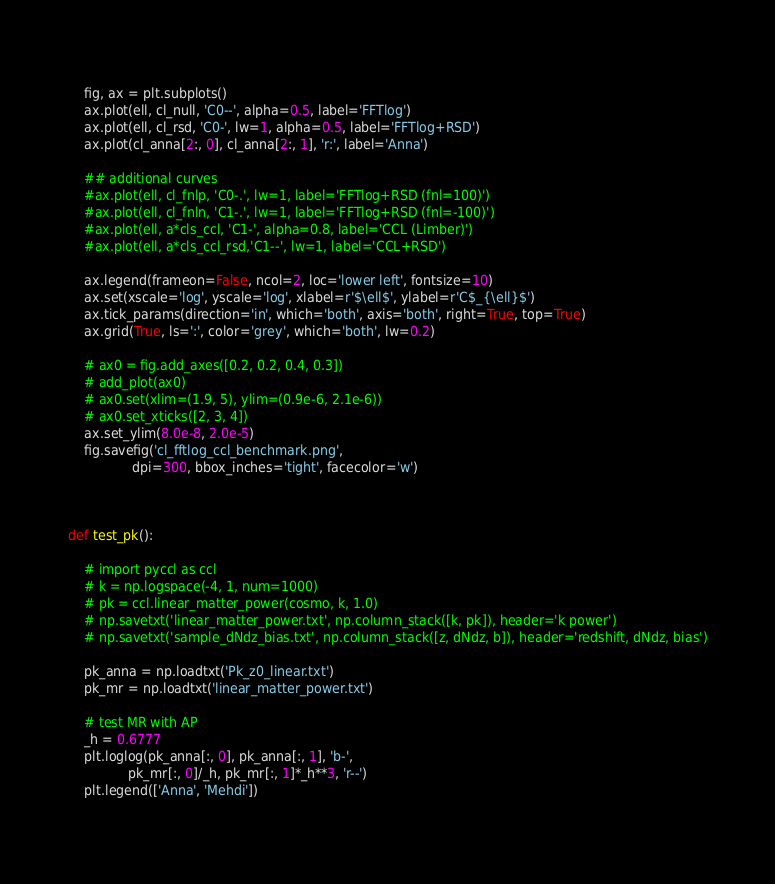Convert code to text. <code><loc_0><loc_0><loc_500><loc_500><_Python_>    
    fig, ax = plt.subplots()
    ax.plot(ell, cl_null, 'C0--', alpha=0.5, label='FFTlog')
    ax.plot(ell, cl_rsd, 'C0-', lw=1, alpha=0.5, label='FFTlog+RSD')
    ax.plot(cl_anna[2:, 0], cl_anna[2:, 1], 'r:', label='Anna')
    
    ## additional curves
    #ax.plot(ell, cl_fnlp, 'C0-.', lw=1, label='FFTlog+RSD (fnl=100)')   
    #ax.plot(ell, cl_fnln, 'C1-.', lw=1, label='FFTlog+RSD (fnl=-100)')    
    #ax.plot(ell, a*cls_ccl, 'C1-', alpha=0.8, label='CCL (Limber)')
    #ax.plot(ell, a*cls_ccl_rsd,'C1--', lw=1, label='CCL+RSD')

    ax.legend(frameon=False, ncol=2, loc='lower left', fontsize=10)
    ax.set(xscale='log', yscale='log', xlabel=r'$\ell$', ylabel=r'C$_{\ell}$')
    ax.tick_params(direction='in', which='both', axis='both', right=True, top=True)
    ax.grid(True, ls=':', color='grey', which='both', lw=0.2)

    # ax0 = fig.add_axes([0.2, 0.2, 0.4, 0.3])
    # add_plot(ax0)
    # ax0.set(xlim=(1.9, 5), ylim=(0.9e-6, 2.1e-6))
    # ax0.set_xticks([2, 3, 4])
    ax.set_ylim(8.0e-8, 2.0e-5)
    fig.savefig('cl_fftlog_ccl_benchmark.png', 
                dpi=300, bbox_inches='tight', facecolor='w')    

    
    
def test_pk():
    
    # import pyccl as ccl
    # k = np.logspace(-4, 1, num=1000)
    # pk = ccl.linear_matter_power(cosmo, k, 1.0)
    # np.savetxt('linear_matter_power.txt', np.column_stack([k, pk]), header='k power')
    # np.savetxt('sample_dNdz_bias.txt', np.column_stack([z, dNdz, b]), header='redshift, dNdz, bias')
    
    pk_anna = np.loadtxt('Pk_z0_linear.txt')
    pk_mr = np.loadtxt('linear_matter_power.txt')
    
    # test MR with AP
    _h = 0.6777
    plt.loglog(pk_anna[:, 0], pk_anna[:, 1], 'b-',
               pk_mr[:, 0]/_h, pk_mr[:, 1]*_h**3, 'r--')
    plt.legend(['Anna', 'Mehdi'])    
    </code> 